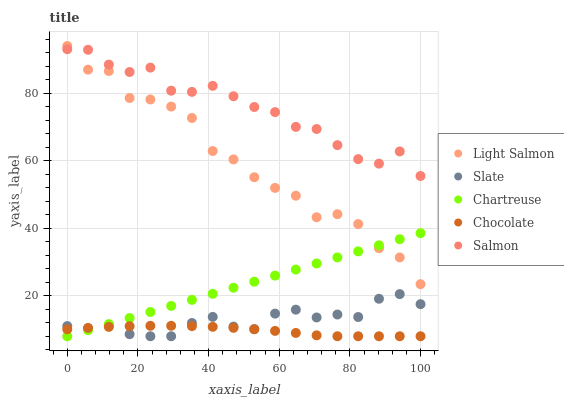Does Chocolate have the minimum area under the curve?
Answer yes or no. Yes. Does Salmon have the maximum area under the curve?
Answer yes or no. Yes. Does Slate have the minimum area under the curve?
Answer yes or no. No. Does Slate have the maximum area under the curve?
Answer yes or no. No. Is Chartreuse the smoothest?
Answer yes or no. Yes. Is Light Salmon the roughest?
Answer yes or no. Yes. Is Salmon the smoothest?
Answer yes or no. No. Is Salmon the roughest?
Answer yes or no. No. Does Slate have the lowest value?
Answer yes or no. Yes. Does Salmon have the lowest value?
Answer yes or no. No. Does Light Salmon have the highest value?
Answer yes or no. Yes. Does Salmon have the highest value?
Answer yes or no. No. Is Chartreuse less than Salmon?
Answer yes or no. Yes. Is Salmon greater than Slate?
Answer yes or no. Yes. Does Light Salmon intersect Chartreuse?
Answer yes or no. Yes. Is Light Salmon less than Chartreuse?
Answer yes or no. No. Is Light Salmon greater than Chartreuse?
Answer yes or no. No. Does Chartreuse intersect Salmon?
Answer yes or no. No. 